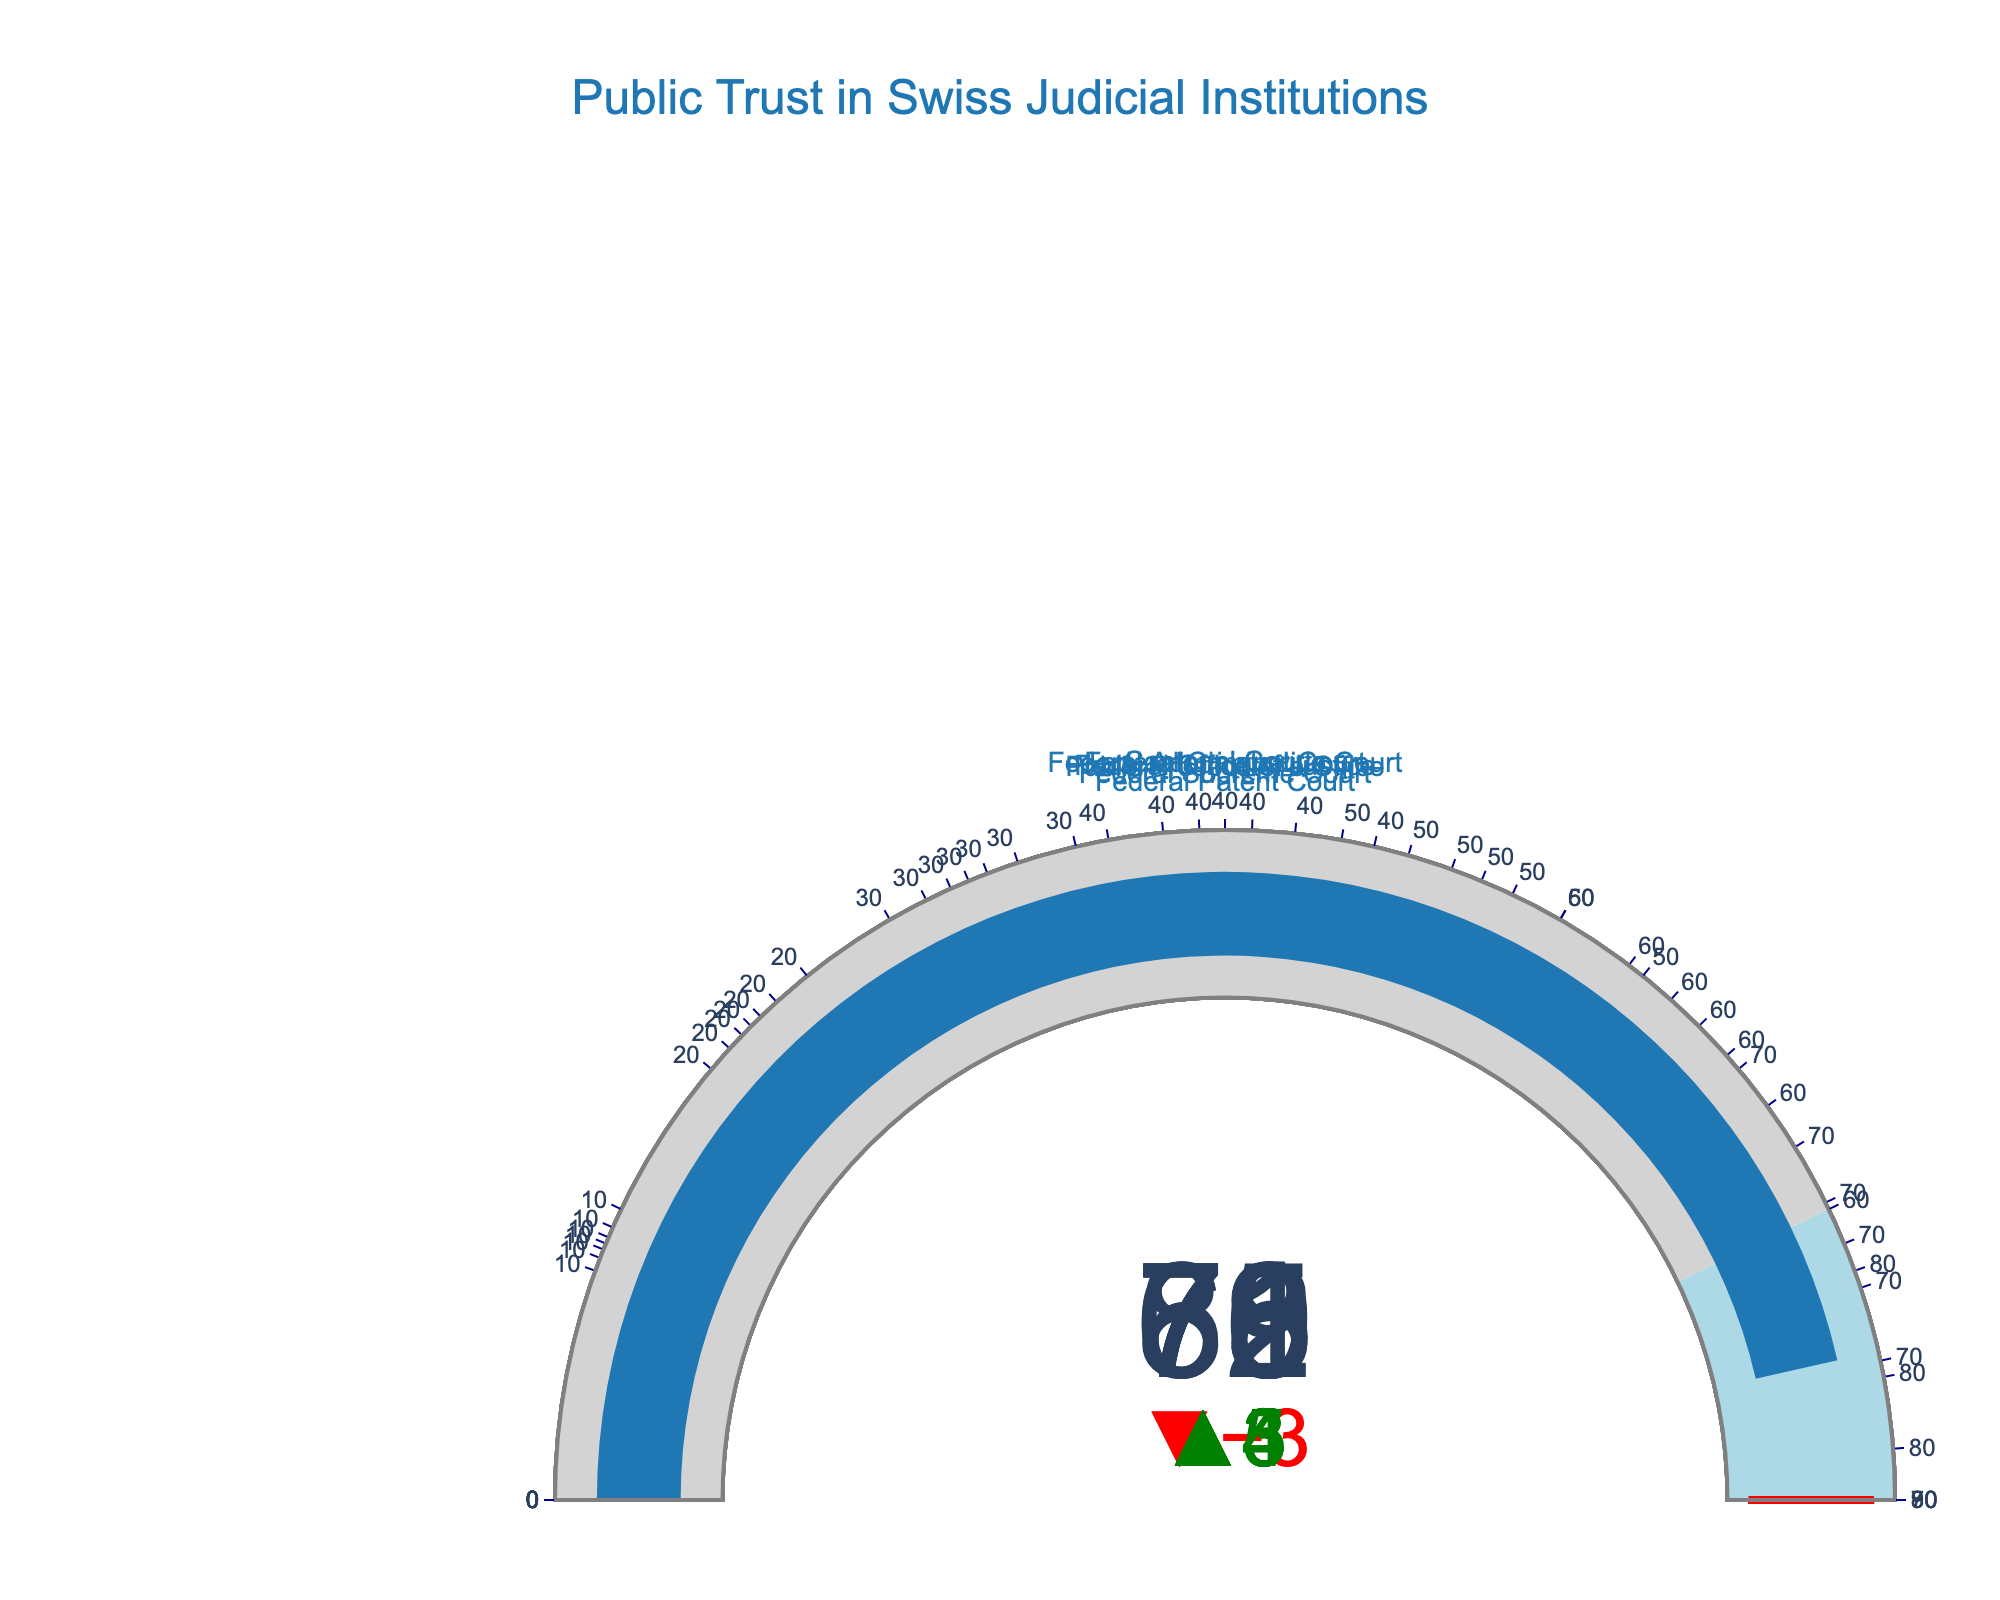What's the title of the figure? The figure's title is at the top and usually gives an overview of what the chart is about.
Answer: Public Trust in Swiss Judicial Institutions Which institution currently has the highest trust level? The institution with the highest trust level can be identified by looking for the highest number in the "Current Trust Level" values.
Answer: Federal Supreme Court How much did the public trust level in the Federal Criminal Court increase compared to the historical benchmark? To find the increase, subtract the historical benchmark value from the current trust level value. For the Federal Criminal Court: 76 - 72.
Answer: 4 Which institution has the smallest gap between the current trust level and the target? To determine the smallest gap, find the difference between the current trust level and the target for each institution and identify the smallest difference.
Answer: Federal Patent Court (5) Which institution's current trust level is below its historical benchmark? Identify institutions where the current trust level is less than the historical benchmark by comparing the two values for each institution.
Answer: Federal Supreme Court What is the average current trust level across all institutions? To calculate the average, sum the current trust levels of all institutions and divide by the number of institutions. (82 + 78 + 73 + 76 + 71 + 69 + 65) / 7
Answer: 73.43 Which institution is closest to its target trust level? Compare the current trust level of each institution to its target and find the smallest difference.
Answer: Federal Office of Justice What is the average historical benchmark among all institutions? Sum the historical benchmark values of all institutions and divide by the number of institutions. (85 + 75 + 70 + 72 + 68 + 65 + 60) / 7
Answer: 70.71 Which institution has the highest target trust level? Look for the institution with the highest number in the "Target" column.
Answer: Federal Supreme Court Are there any institutions where the current trust level exactly matches the historical benchmark? Compare the current trust level to the historical benchmark for each institution to see if any match exactly.
Answer: No 